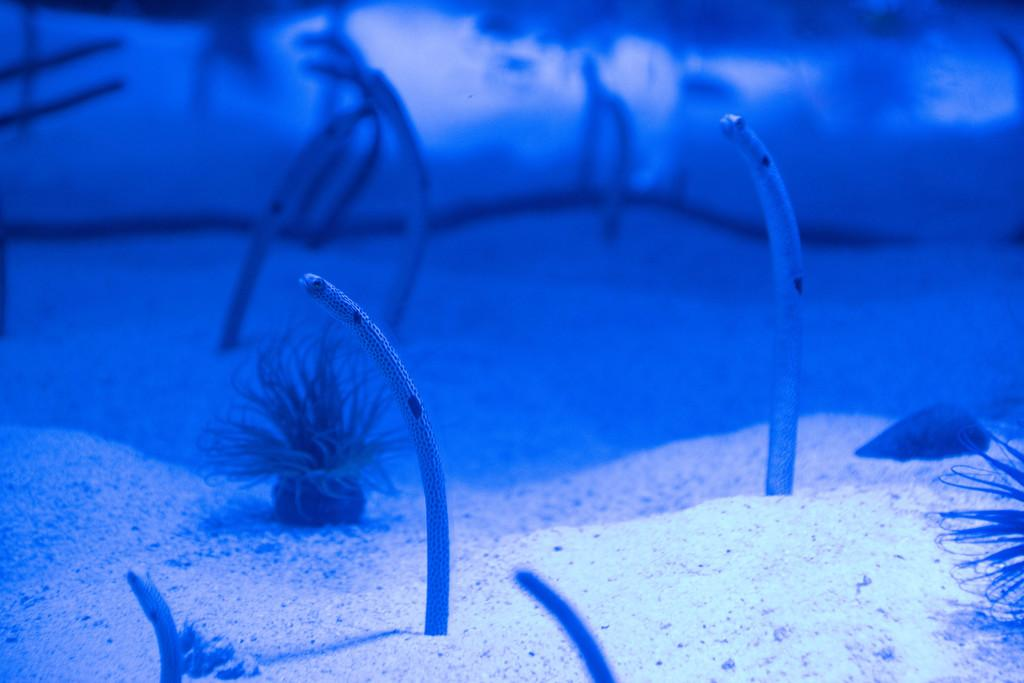What is the setting of the image? The image is taken underwater. What type of animals can be seen in the image? There are snakes in the image. What type of terrain is visible in the image? There is sand visible in the image. What type of apparel is being advertised on the floor in the image? There is no app or advertisement present in the image; it is taken underwater with snakes and sand visible. 